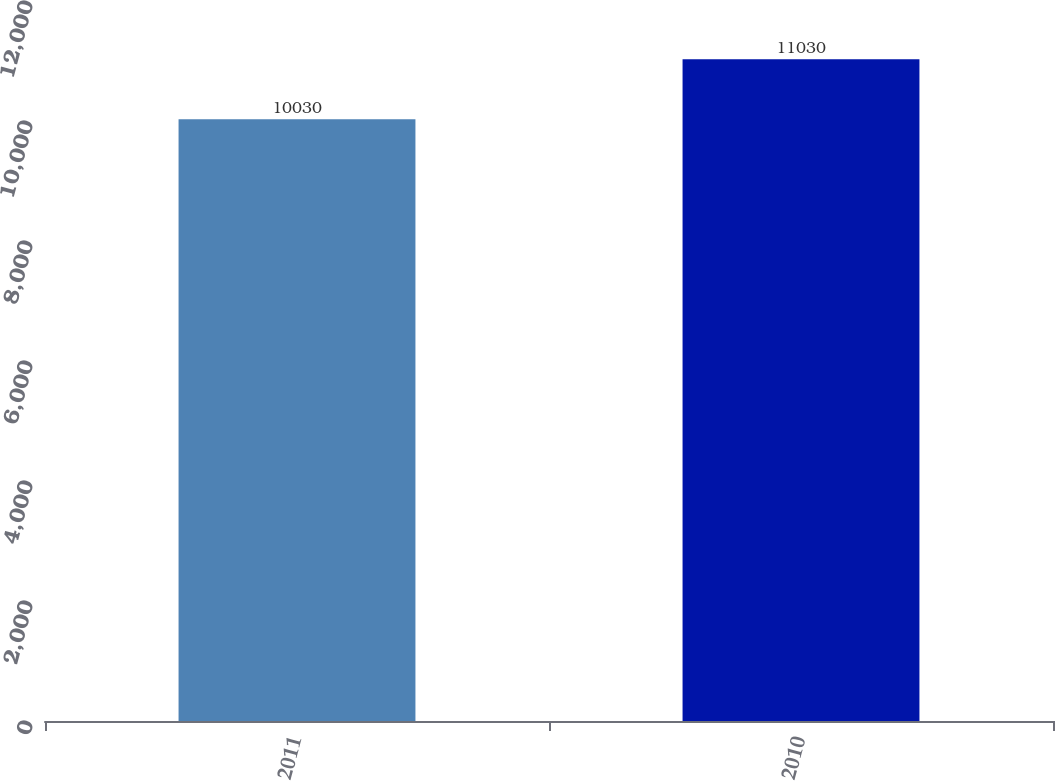Convert chart to OTSL. <chart><loc_0><loc_0><loc_500><loc_500><bar_chart><fcel>2011<fcel>2010<nl><fcel>10030<fcel>11030<nl></chart> 